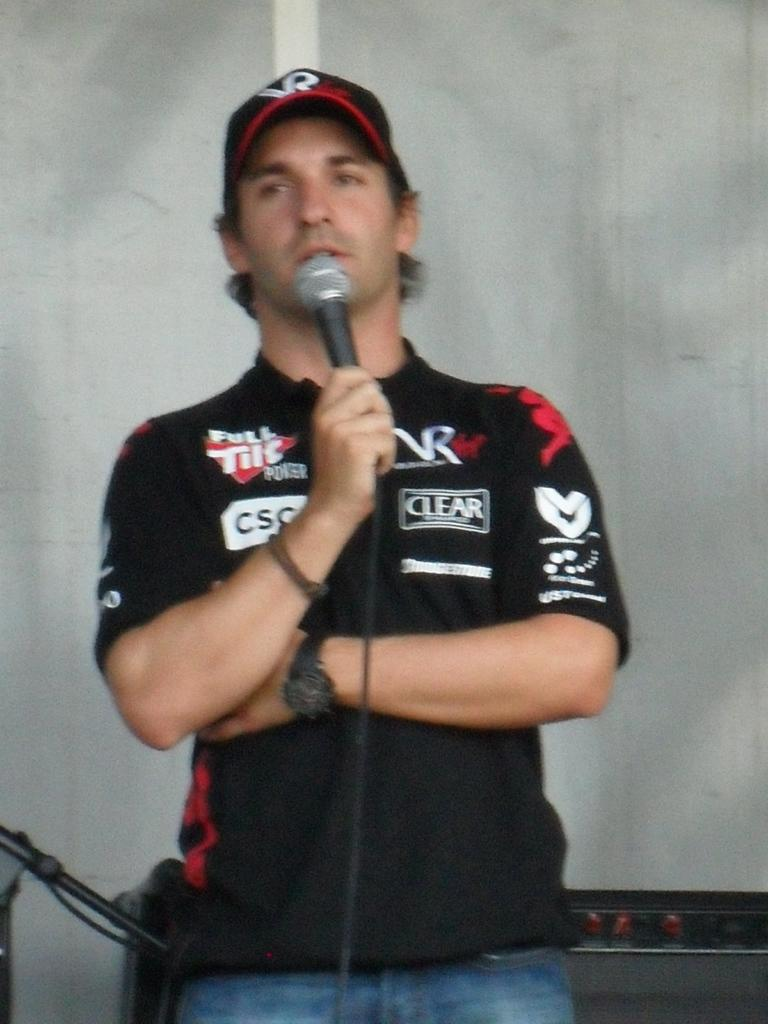Who is the main subject in the image? There is a man in the image. What is the man wearing on his upper body? The man is wearing a black shirt. Is the man wearing any headgear in the image? Yes, the man is wearing a hat. What is the man holding in his right hand? The man is holding a mic in his right hand. What type of polish is the man applying to his shoes in the image? There is no indication in the image that the man is applying polish to his shoes, and shoes are not even mentioned in the facts provided. 